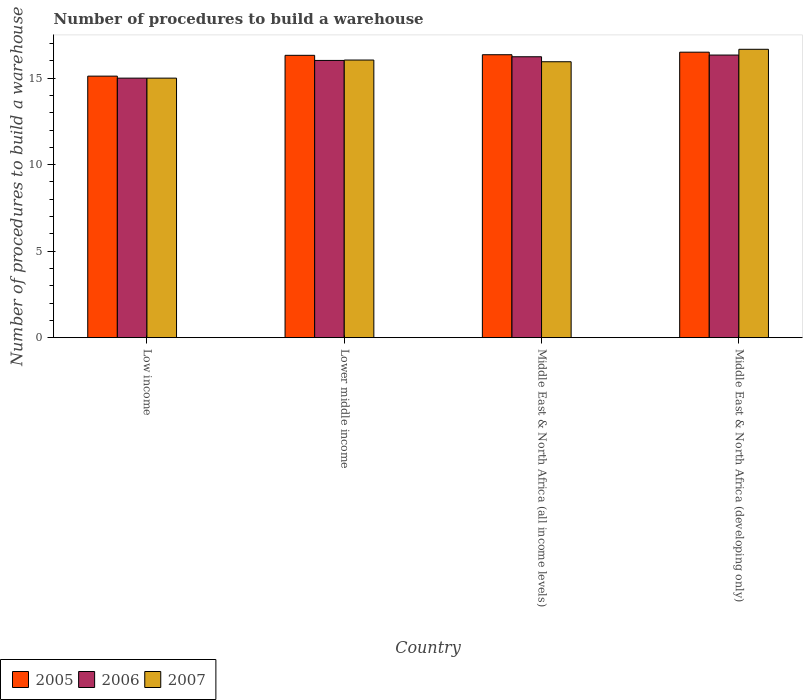Are the number of bars on each tick of the X-axis equal?
Your answer should be very brief. Yes. What is the label of the 3rd group of bars from the left?
Provide a short and direct response. Middle East & North Africa (all income levels). What is the number of procedures to build a warehouse in in 2006 in Middle East & North Africa (all income levels)?
Offer a terse response. 16.24. Across all countries, what is the maximum number of procedures to build a warehouse in in 2006?
Offer a terse response. 16.33. Across all countries, what is the minimum number of procedures to build a warehouse in in 2007?
Your answer should be very brief. 15. In which country was the number of procedures to build a warehouse in in 2007 maximum?
Offer a very short reply. Middle East & North Africa (developing only). What is the total number of procedures to build a warehouse in in 2007 in the graph?
Provide a short and direct response. 63.66. What is the difference between the number of procedures to build a warehouse in in 2007 in Middle East & North Africa (all income levels) and that in Middle East & North Africa (developing only)?
Provide a succinct answer. -0.72. What is the difference between the number of procedures to build a warehouse in in 2005 in Middle East & North Africa (developing only) and the number of procedures to build a warehouse in in 2006 in Middle East & North Africa (all income levels)?
Offer a terse response. 0.26. What is the average number of procedures to build a warehouse in in 2007 per country?
Your answer should be very brief. 15.91. What is the difference between the number of procedures to build a warehouse in of/in 2007 and number of procedures to build a warehouse in of/in 2005 in Lower middle income?
Your response must be concise. -0.27. What is the ratio of the number of procedures to build a warehouse in in 2005 in Low income to that in Lower middle income?
Offer a very short reply. 0.93. Is the number of procedures to build a warehouse in in 2007 in Middle East & North Africa (all income levels) less than that in Middle East & North Africa (developing only)?
Provide a succinct answer. Yes. Is the difference between the number of procedures to build a warehouse in in 2007 in Lower middle income and Middle East & North Africa (all income levels) greater than the difference between the number of procedures to build a warehouse in in 2005 in Lower middle income and Middle East & North Africa (all income levels)?
Your response must be concise. Yes. What is the difference between the highest and the second highest number of procedures to build a warehouse in in 2007?
Offer a terse response. 0.62. What is the difference between the highest and the lowest number of procedures to build a warehouse in in 2007?
Keep it short and to the point. 1.67. What does the 1st bar from the right in Lower middle income represents?
Keep it short and to the point. 2007. Is it the case that in every country, the sum of the number of procedures to build a warehouse in in 2006 and number of procedures to build a warehouse in in 2005 is greater than the number of procedures to build a warehouse in in 2007?
Provide a short and direct response. Yes. How many bars are there?
Offer a terse response. 12. Are all the bars in the graph horizontal?
Make the answer very short. No. How many countries are there in the graph?
Make the answer very short. 4. Are the values on the major ticks of Y-axis written in scientific E-notation?
Provide a short and direct response. No. Does the graph contain grids?
Ensure brevity in your answer.  No. Where does the legend appear in the graph?
Give a very brief answer. Bottom left. How are the legend labels stacked?
Offer a terse response. Horizontal. What is the title of the graph?
Offer a very short reply. Number of procedures to build a warehouse. Does "1999" appear as one of the legend labels in the graph?
Provide a short and direct response. No. What is the label or title of the Y-axis?
Provide a short and direct response. Number of procedures to build a warehouse. What is the Number of procedures to build a warehouse of 2005 in Low income?
Keep it short and to the point. 15.12. What is the Number of procedures to build a warehouse in 2006 in Low income?
Ensure brevity in your answer.  15. What is the Number of procedures to build a warehouse in 2005 in Lower middle income?
Your answer should be compact. 16.32. What is the Number of procedures to build a warehouse of 2006 in Lower middle income?
Your response must be concise. 16.02. What is the Number of procedures to build a warehouse of 2007 in Lower middle income?
Give a very brief answer. 16.05. What is the Number of procedures to build a warehouse of 2005 in Middle East & North Africa (all income levels)?
Provide a short and direct response. 16.35. What is the Number of procedures to build a warehouse of 2006 in Middle East & North Africa (all income levels)?
Your answer should be very brief. 16.24. What is the Number of procedures to build a warehouse of 2007 in Middle East & North Africa (all income levels)?
Keep it short and to the point. 15.95. What is the Number of procedures to build a warehouse in 2006 in Middle East & North Africa (developing only)?
Give a very brief answer. 16.33. What is the Number of procedures to build a warehouse in 2007 in Middle East & North Africa (developing only)?
Give a very brief answer. 16.67. Across all countries, what is the maximum Number of procedures to build a warehouse of 2006?
Provide a short and direct response. 16.33. Across all countries, what is the maximum Number of procedures to build a warehouse in 2007?
Your answer should be very brief. 16.67. Across all countries, what is the minimum Number of procedures to build a warehouse of 2005?
Your answer should be compact. 15.12. Across all countries, what is the minimum Number of procedures to build a warehouse in 2007?
Your response must be concise. 15. What is the total Number of procedures to build a warehouse in 2005 in the graph?
Your answer should be compact. 64.29. What is the total Number of procedures to build a warehouse of 2006 in the graph?
Provide a short and direct response. 63.59. What is the total Number of procedures to build a warehouse of 2007 in the graph?
Your answer should be compact. 63.66. What is the difference between the Number of procedures to build a warehouse in 2005 in Low income and that in Lower middle income?
Make the answer very short. -1.2. What is the difference between the Number of procedures to build a warehouse of 2006 in Low income and that in Lower middle income?
Offer a terse response. -1.02. What is the difference between the Number of procedures to build a warehouse in 2007 in Low income and that in Lower middle income?
Your answer should be very brief. -1.05. What is the difference between the Number of procedures to build a warehouse of 2005 in Low income and that in Middle East & North Africa (all income levels)?
Your response must be concise. -1.24. What is the difference between the Number of procedures to build a warehouse of 2006 in Low income and that in Middle East & North Africa (all income levels)?
Your response must be concise. -1.24. What is the difference between the Number of procedures to build a warehouse of 2007 in Low income and that in Middle East & North Africa (all income levels)?
Your answer should be very brief. -0.95. What is the difference between the Number of procedures to build a warehouse of 2005 in Low income and that in Middle East & North Africa (developing only)?
Make the answer very short. -1.38. What is the difference between the Number of procedures to build a warehouse of 2006 in Low income and that in Middle East & North Africa (developing only)?
Make the answer very short. -1.33. What is the difference between the Number of procedures to build a warehouse of 2007 in Low income and that in Middle East & North Africa (developing only)?
Your response must be concise. -1.67. What is the difference between the Number of procedures to build a warehouse in 2005 in Lower middle income and that in Middle East & North Africa (all income levels)?
Your answer should be compact. -0.03. What is the difference between the Number of procedures to build a warehouse of 2006 in Lower middle income and that in Middle East & North Africa (all income levels)?
Ensure brevity in your answer.  -0.21. What is the difference between the Number of procedures to build a warehouse of 2007 in Lower middle income and that in Middle East & North Africa (all income levels)?
Offer a terse response. 0.1. What is the difference between the Number of procedures to build a warehouse of 2005 in Lower middle income and that in Middle East & North Africa (developing only)?
Make the answer very short. -0.18. What is the difference between the Number of procedures to build a warehouse of 2006 in Lower middle income and that in Middle East & North Africa (developing only)?
Keep it short and to the point. -0.31. What is the difference between the Number of procedures to build a warehouse of 2007 in Lower middle income and that in Middle East & North Africa (developing only)?
Ensure brevity in your answer.  -0.62. What is the difference between the Number of procedures to build a warehouse of 2005 in Middle East & North Africa (all income levels) and that in Middle East & North Africa (developing only)?
Provide a succinct answer. -0.15. What is the difference between the Number of procedures to build a warehouse in 2006 in Middle East & North Africa (all income levels) and that in Middle East & North Africa (developing only)?
Provide a short and direct response. -0.1. What is the difference between the Number of procedures to build a warehouse of 2007 in Middle East & North Africa (all income levels) and that in Middle East & North Africa (developing only)?
Keep it short and to the point. -0.72. What is the difference between the Number of procedures to build a warehouse in 2005 in Low income and the Number of procedures to build a warehouse in 2006 in Lower middle income?
Your answer should be compact. -0.91. What is the difference between the Number of procedures to build a warehouse of 2005 in Low income and the Number of procedures to build a warehouse of 2007 in Lower middle income?
Your answer should be compact. -0.93. What is the difference between the Number of procedures to build a warehouse in 2006 in Low income and the Number of procedures to build a warehouse in 2007 in Lower middle income?
Make the answer very short. -1.05. What is the difference between the Number of procedures to build a warehouse in 2005 in Low income and the Number of procedures to build a warehouse in 2006 in Middle East & North Africa (all income levels)?
Keep it short and to the point. -1.12. What is the difference between the Number of procedures to build a warehouse in 2005 in Low income and the Number of procedures to build a warehouse in 2007 in Middle East & North Africa (all income levels)?
Your answer should be compact. -0.83. What is the difference between the Number of procedures to build a warehouse in 2006 in Low income and the Number of procedures to build a warehouse in 2007 in Middle East & North Africa (all income levels)?
Make the answer very short. -0.95. What is the difference between the Number of procedures to build a warehouse of 2005 in Low income and the Number of procedures to build a warehouse of 2006 in Middle East & North Africa (developing only)?
Provide a succinct answer. -1.22. What is the difference between the Number of procedures to build a warehouse of 2005 in Low income and the Number of procedures to build a warehouse of 2007 in Middle East & North Africa (developing only)?
Offer a very short reply. -1.55. What is the difference between the Number of procedures to build a warehouse of 2006 in Low income and the Number of procedures to build a warehouse of 2007 in Middle East & North Africa (developing only)?
Provide a short and direct response. -1.67. What is the difference between the Number of procedures to build a warehouse of 2005 in Lower middle income and the Number of procedures to build a warehouse of 2006 in Middle East & North Africa (all income levels)?
Ensure brevity in your answer.  0.08. What is the difference between the Number of procedures to build a warehouse in 2005 in Lower middle income and the Number of procedures to build a warehouse in 2007 in Middle East & North Africa (all income levels)?
Provide a short and direct response. 0.37. What is the difference between the Number of procedures to build a warehouse of 2006 in Lower middle income and the Number of procedures to build a warehouse of 2007 in Middle East & North Africa (all income levels)?
Provide a short and direct response. 0.08. What is the difference between the Number of procedures to build a warehouse of 2005 in Lower middle income and the Number of procedures to build a warehouse of 2006 in Middle East & North Africa (developing only)?
Your response must be concise. -0.02. What is the difference between the Number of procedures to build a warehouse in 2005 in Lower middle income and the Number of procedures to build a warehouse in 2007 in Middle East & North Africa (developing only)?
Offer a terse response. -0.35. What is the difference between the Number of procedures to build a warehouse in 2006 in Lower middle income and the Number of procedures to build a warehouse in 2007 in Middle East & North Africa (developing only)?
Provide a succinct answer. -0.64. What is the difference between the Number of procedures to build a warehouse in 2005 in Middle East & North Africa (all income levels) and the Number of procedures to build a warehouse in 2006 in Middle East & North Africa (developing only)?
Offer a terse response. 0.02. What is the difference between the Number of procedures to build a warehouse in 2005 in Middle East & North Africa (all income levels) and the Number of procedures to build a warehouse in 2007 in Middle East & North Africa (developing only)?
Make the answer very short. -0.31. What is the difference between the Number of procedures to build a warehouse of 2006 in Middle East & North Africa (all income levels) and the Number of procedures to build a warehouse of 2007 in Middle East & North Africa (developing only)?
Offer a very short reply. -0.43. What is the average Number of procedures to build a warehouse of 2005 per country?
Your answer should be compact. 16.07. What is the average Number of procedures to build a warehouse of 2006 per country?
Offer a terse response. 15.9. What is the average Number of procedures to build a warehouse of 2007 per country?
Your answer should be compact. 15.91. What is the difference between the Number of procedures to build a warehouse of 2005 and Number of procedures to build a warehouse of 2006 in Low income?
Offer a very short reply. 0.12. What is the difference between the Number of procedures to build a warehouse in 2005 and Number of procedures to build a warehouse in 2007 in Low income?
Provide a succinct answer. 0.12. What is the difference between the Number of procedures to build a warehouse of 2005 and Number of procedures to build a warehouse of 2006 in Lower middle income?
Provide a short and direct response. 0.3. What is the difference between the Number of procedures to build a warehouse of 2005 and Number of procedures to build a warehouse of 2007 in Lower middle income?
Ensure brevity in your answer.  0.27. What is the difference between the Number of procedures to build a warehouse of 2006 and Number of procedures to build a warehouse of 2007 in Lower middle income?
Provide a succinct answer. -0.02. What is the difference between the Number of procedures to build a warehouse in 2005 and Number of procedures to build a warehouse in 2006 in Middle East & North Africa (all income levels)?
Provide a short and direct response. 0.12. What is the difference between the Number of procedures to build a warehouse in 2005 and Number of procedures to build a warehouse in 2007 in Middle East & North Africa (all income levels)?
Your answer should be very brief. 0.41. What is the difference between the Number of procedures to build a warehouse of 2006 and Number of procedures to build a warehouse of 2007 in Middle East & North Africa (all income levels)?
Your answer should be very brief. 0.29. What is the difference between the Number of procedures to build a warehouse in 2005 and Number of procedures to build a warehouse in 2007 in Middle East & North Africa (developing only)?
Provide a short and direct response. -0.17. What is the difference between the Number of procedures to build a warehouse of 2006 and Number of procedures to build a warehouse of 2007 in Middle East & North Africa (developing only)?
Give a very brief answer. -0.33. What is the ratio of the Number of procedures to build a warehouse of 2005 in Low income to that in Lower middle income?
Offer a very short reply. 0.93. What is the ratio of the Number of procedures to build a warehouse in 2006 in Low income to that in Lower middle income?
Provide a succinct answer. 0.94. What is the ratio of the Number of procedures to build a warehouse in 2007 in Low income to that in Lower middle income?
Keep it short and to the point. 0.93. What is the ratio of the Number of procedures to build a warehouse in 2005 in Low income to that in Middle East & North Africa (all income levels)?
Provide a short and direct response. 0.92. What is the ratio of the Number of procedures to build a warehouse of 2006 in Low income to that in Middle East & North Africa (all income levels)?
Provide a succinct answer. 0.92. What is the ratio of the Number of procedures to build a warehouse in 2007 in Low income to that in Middle East & North Africa (all income levels)?
Provide a succinct answer. 0.94. What is the ratio of the Number of procedures to build a warehouse of 2005 in Low income to that in Middle East & North Africa (developing only)?
Make the answer very short. 0.92. What is the ratio of the Number of procedures to build a warehouse in 2006 in Low income to that in Middle East & North Africa (developing only)?
Provide a succinct answer. 0.92. What is the ratio of the Number of procedures to build a warehouse of 2005 in Lower middle income to that in Middle East & North Africa (all income levels)?
Offer a very short reply. 1. What is the ratio of the Number of procedures to build a warehouse of 2006 in Lower middle income to that in Middle East & North Africa (all income levels)?
Ensure brevity in your answer.  0.99. What is the ratio of the Number of procedures to build a warehouse in 2007 in Lower middle income to that in Middle East & North Africa (all income levels)?
Ensure brevity in your answer.  1.01. What is the ratio of the Number of procedures to build a warehouse of 2005 in Lower middle income to that in Middle East & North Africa (developing only)?
Your answer should be very brief. 0.99. What is the ratio of the Number of procedures to build a warehouse in 2007 in Lower middle income to that in Middle East & North Africa (developing only)?
Your response must be concise. 0.96. What is the ratio of the Number of procedures to build a warehouse in 2006 in Middle East & North Africa (all income levels) to that in Middle East & North Africa (developing only)?
Give a very brief answer. 0.99. What is the ratio of the Number of procedures to build a warehouse of 2007 in Middle East & North Africa (all income levels) to that in Middle East & North Africa (developing only)?
Provide a succinct answer. 0.96. What is the difference between the highest and the second highest Number of procedures to build a warehouse of 2005?
Your answer should be compact. 0.15. What is the difference between the highest and the second highest Number of procedures to build a warehouse of 2006?
Keep it short and to the point. 0.1. What is the difference between the highest and the second highest Number of procedures to build a warehouse in 2007?
Offer a very short reply. 0.62. What is the difference between the highest and the lowest Number of procedures to build a warehouse of 2005?
Your response must be concise. 1.38. 